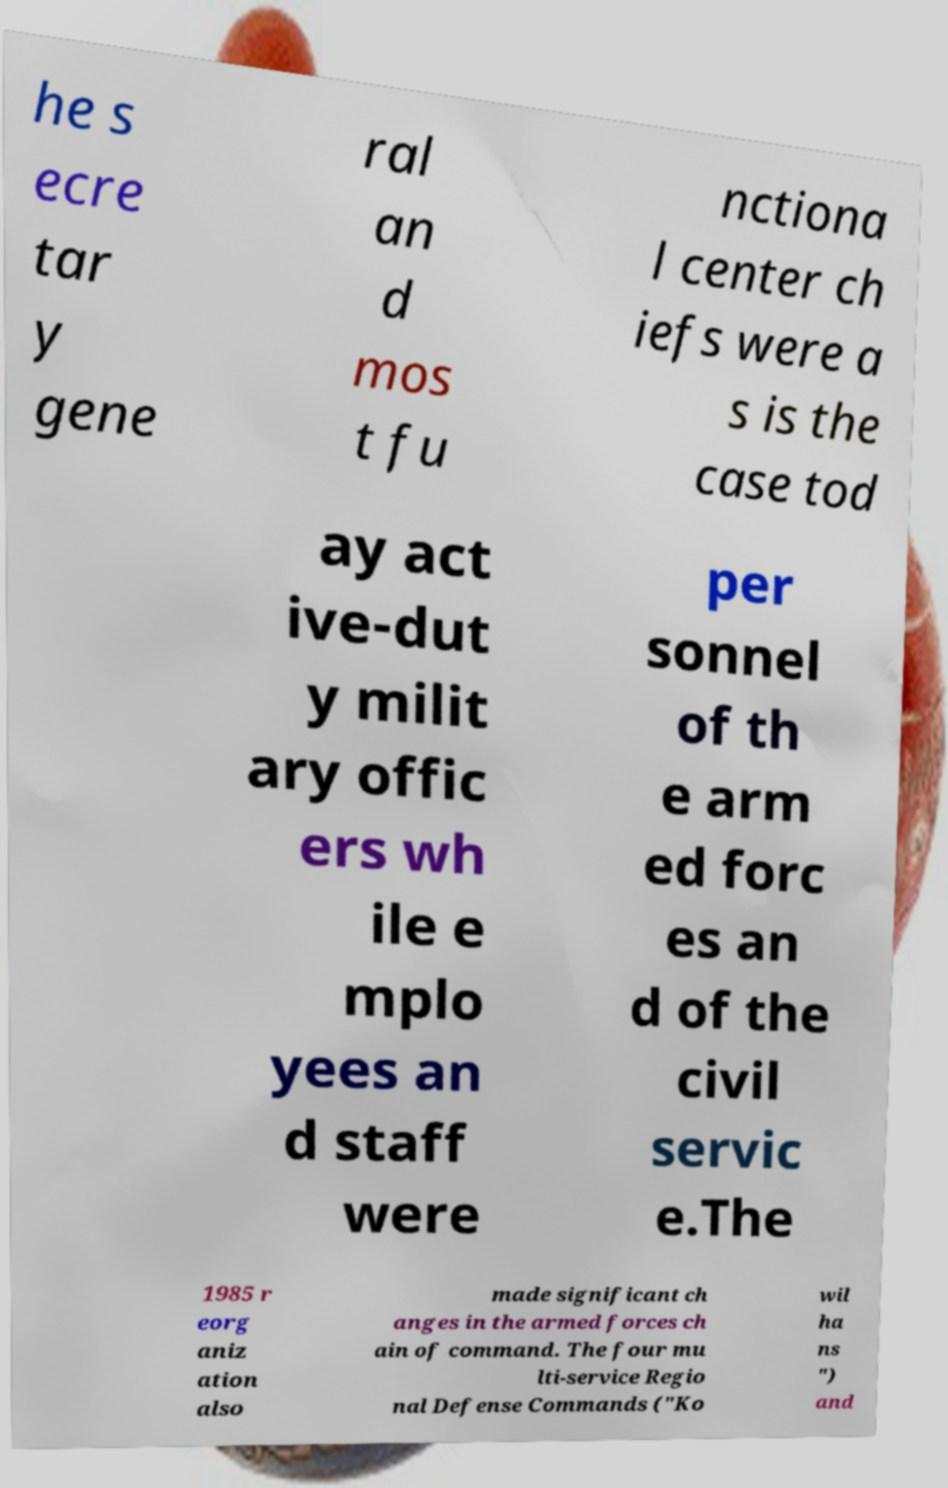Could you extract and type out the text from this image? he s ecre tar y gene ral an d mos t fu nctiona l center ch iefs were a s is the case tod ay act ive-dut y milit ary offic ers wh ile e mplo yees an d staff were per sonnel of th e arm ed forc es an d of the civil servic e.The 1985 r eorg aniz ation also made significant ch anges in the armed forces ch ain of command. The four mu lti-service Regio nal Defense Commands ("Ko wil ha ns ") and 